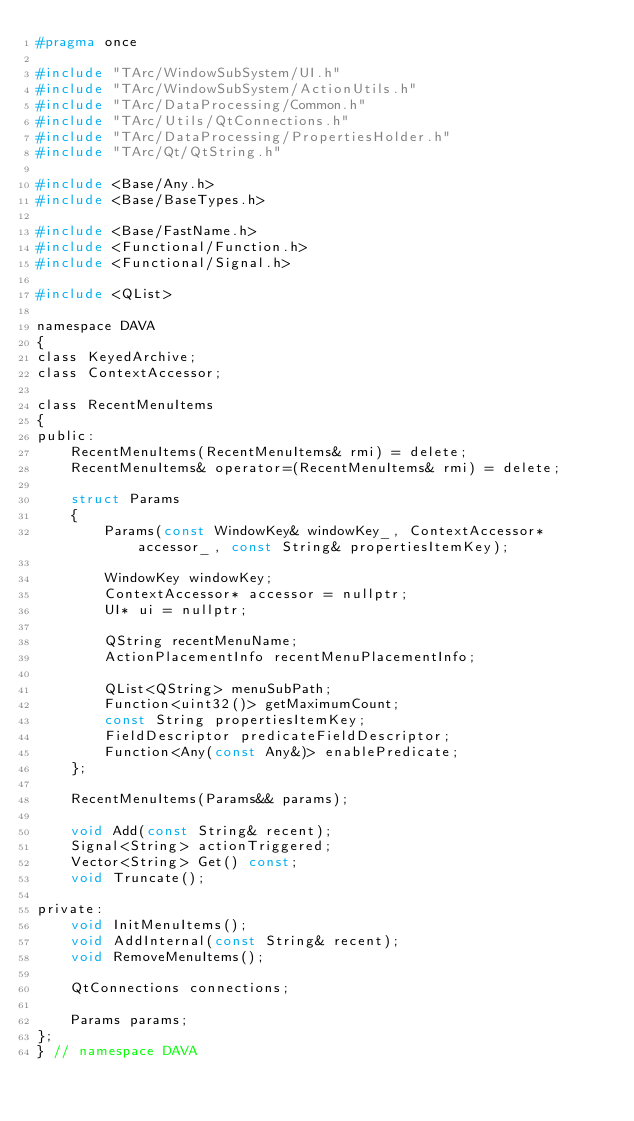<code> <loc_0><loc_0><loc_500><loc_500><_C_>#pragma once

#include "TArc/WindowSubSystem/UI.h"
#include "TArc/WindowSubSystem/ActionUtils.h"
#include "TArc/DataProcessing/Common.h"
#include "TArc/Utils/QtConnections.h"
#include "TArc/DataProcessing/PropertiesHolder.h"
#include "TArc/Qt/QtString.h"

#include <Base/Any.h>
#include <Base/BaseTypes.h>

#include <Base/FastName.h>
#include <Functional/Function.h>
#include <Functional/Signal.h>

#include <QList>

namespace DAVA
{
class KeyedArchive;
class ContextAccessor;

class RecentMenuItems
{
public:
    RecentMenuItems(RecentMenuItems& rmi) = delete;
    RecentMenuItems& operator=(RecentMenuItems& rmi) = delete;

    struct Params
    {
        Params(const WindowKey& windowKey_, ContextAccessor* accessor_, const String& propertiesItemKey);

        WindowKey windowKey;
        ContextAccessor* accessor = nullptr;
        UI* ui = nullptr;

        QString recentMenuName;
        ActionPlacementInfo recentMenuPlacementInfo;

        QList<QString> menuSubPath;
        Function<uint32()> getMaximumCount;
        const String propertiesItemKey;
        FieldDescriptor predicateFieldDescriptor;
        Function<Any(const Any&)> enablePredicate;
    };

    RecentMenuItems(Params&& params);

    void Add(const String& recent);
    Signal<String> actionTriggered;
    Vector<String> Get() const;
    void Truncate();

private:
    void InitMenuItems();
    void AddInternal(const String& recent);
    void RemoveMenuItems();

    QtConnections connections;

    Params params;
};
} // namespace DAVA
</code> 